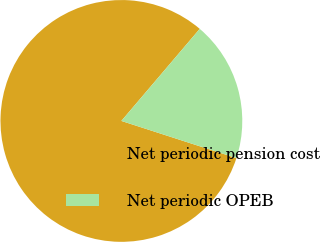<chart> <loc_0><loc_0><loc_500><loc_500><pie_chart><fcel>Net periodic pension cost<fcel>Net periodic OPEB<nl><fcel>81.25%<fcel>18.75%<nl></chart> 